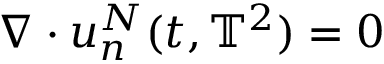Convert formula to latex. <formula><loc_0><loc_0><loc_500><loc_500>\nabla \cdot u _ { n } ^ { N } ( t , \mathbb { T } ^ { 2 } ) = 0</formula> 